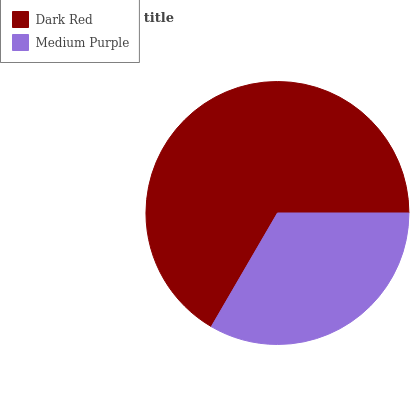Is Medium Purple the minimum?
Answer yes or no. Yes. Is Dark Red the maximum?
Answer yes or no. Yes. Is Medium Purple the maximum?
Answer yes or no. No. Is Dark Red greater than Medium Purple?
Answer yes or no. Yes. Is Medium Purple less than Dark Red?
Answer yes or no. Yes. Is Medium Purple greater than Dark Red?
Answer yes or no. No. Is Dark Red less than Medium Purple?
Answer yes or no. No. Is Dark Red the high median?
Answer yes or no. Yes. Is Medium Purple the low median?
Answer yes or no. Yes. Is Medium Purple the high median?
Answer yes or no. No. Is Dark Red the low median?
Answer yes or no. No. 